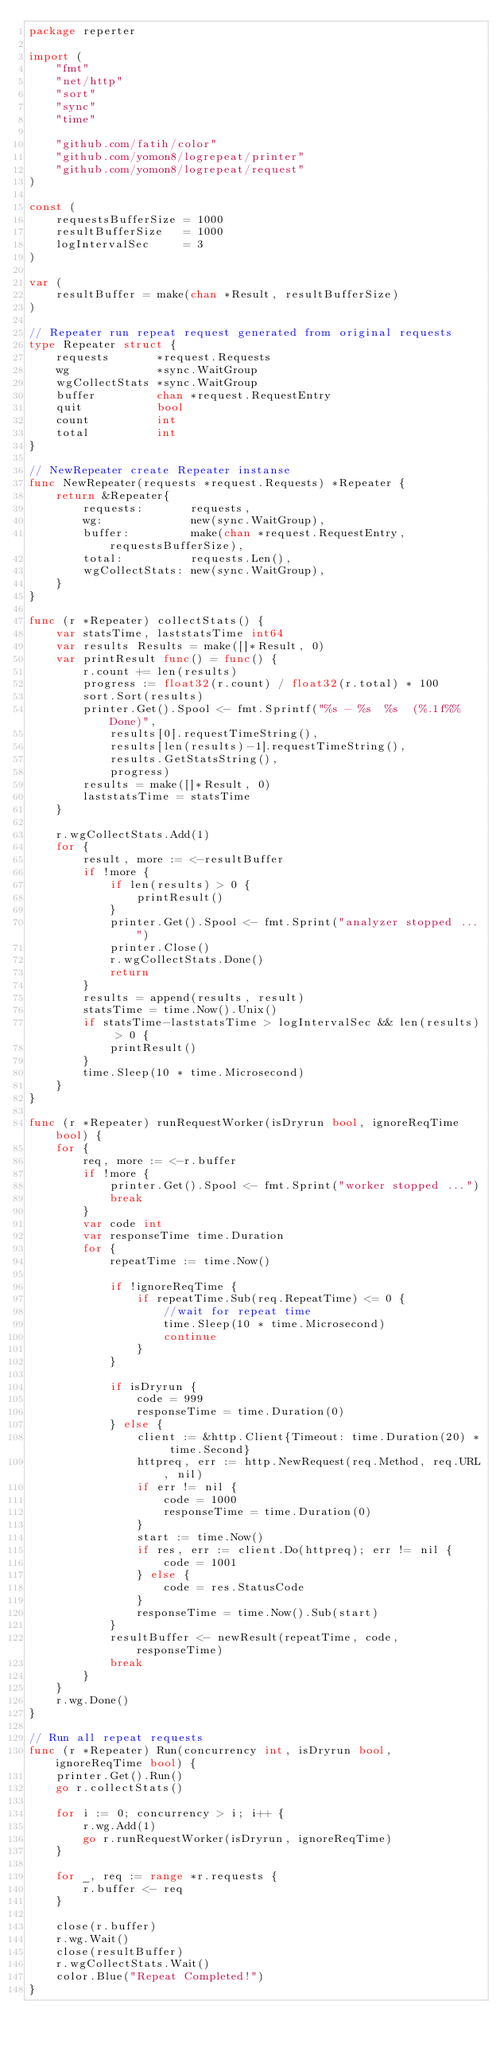Convert code to text. <code><loc_0><loc_0><loc_500><loc_500><_Go_>package reperter

import (
	"fmt"
	"net/http"
	"sort"
	"sync"
	"time"

	"github.com/fatih/color"
	"github.com/yomon8/logrepeat/printer"
	"github.com/yomon8/logrepeat/request"
)

const (
	requestsBufferSize = 1000
	resultBufferSize   = 1000
	logIntervalSec     = 3
)

var (
	resultBuffer = make(chan *Result, resultBufferSize)
)

// Repeater run repeat request generated from original requests
type Repeater struct {
	requests       *request.Requests
	wg             *sync.WaitGroup
	wgCollectStats *sync.WaitGroup
	buffer         chan *request.RequestEntry
	quit           bool
	count          int
	total          int
}

// NewRepeater create Repeater instanse
func NewRepeater(requests *request.Requests) *Repeater {
	return &Repeater{
		requests:       requests,
		wg:             new(sync.WaitGroup),
		buffer:         make(chan *request.RequestEntry, requestsBufferSize),
		total:          requests.Len(),
		wgCollectStats: new(sync.WaitGroup),
	}
}

func (r *Repeater) collectStats() {
	var statsTime, laststatsTime int64
	var results Results = make([]*Result, 0)
	var printResult func() = func() {
		r.count += len(results)
		progress := float32(r.count) / float32(r.total) * 100
		sort.Sort(results)
		printer.Get().Spool <- fmt.Sprintf("%s - %s  %s  (%.1f%%Done)",
			results[0].requestTimeString(),
			results[len(results)-1].requestTimeString(),
			results.GetStatsString(),
			progress)
		results = make([]*Result, 0)
		laststatsTime = statsTime
	}

	r.wgCollectStats.Add(1)
	for {
		result, more := <-resultBuffer
		if !more {
			if len(results) > 0 {
				printResult()
			}
			printer.Get().Spool <- fmt.Sprint("analyzer stopped ...")
			printer.Close()
			r.wgCollectStats.Done()
			return
		}
		results = append(results, result)
		statsTime = time.Now().Unix()
		if statsTime-laststatsTime > logIntervalSec && len(results) > 0 {
			printResult()
		}
		time.Sleep(10 * time.Microsecond)
	}
}

func (r *Repeater) runRequestWorker(isDryrun bool, ignoreReqTime bool) {
	for {
		req, more := <-r.buffer
		if !more {
			printer.Get().Spool <- fmt.Sprint("worker stopped ...")
			break
		}
		var code int
		var responseTime time.Duration
		for {
			repeatTime := time.Now()

			if !ignoreReqTime {
				if repeatTime.Sub(req.RepeatTime) <= 0 {
					//wait for repeat time
					time.Sleep(10 * time.Microsecond)
					continue
				}
			}

			if isDryrun {
				code = 999
				responseTime = time.Duration(0)
			} else {
				client := &http.Client{Timeout: time.Duration(20) * time.Second}
				httpreq, err := http.NewRequest(req.Method, req.URL, nil)
				if err != nil {
					code = 1000
					responseTime = time.Duration(0)
				}
				start := time.Now()
				if res, err := client.Do(httpreq); err != nil {
					code = 1001
				} else {
					code = res.StatusCode
				}
				responseTime = time.Now().Sub(start)
			}
			resultBuffer <- newResult(repeatTime, code, responseTime)
			break
		}
	}
	r.wg.Done()
}

// Run all repeat requests
func (r *Repeater) Run(concurrency int, isDryrun bool, ignoreReqTime bool) {
	printer.Get().Run()
	go r.collectStats()

	for i := 0; concurrency > i; i++ {
		r.wg.Add(1)
		go r.runRequestWorker(isDryrun, ignoreReqTime)
	}

	for _, req := range *r.requests {
		r.buffer <- req
	}

	close(r.buffer)
	r.wg.Wait()
	close(resultBuffer)
	r.wgCollectStats.Wait()
	color.Blue("Repeat Completed!")
}
</code> 